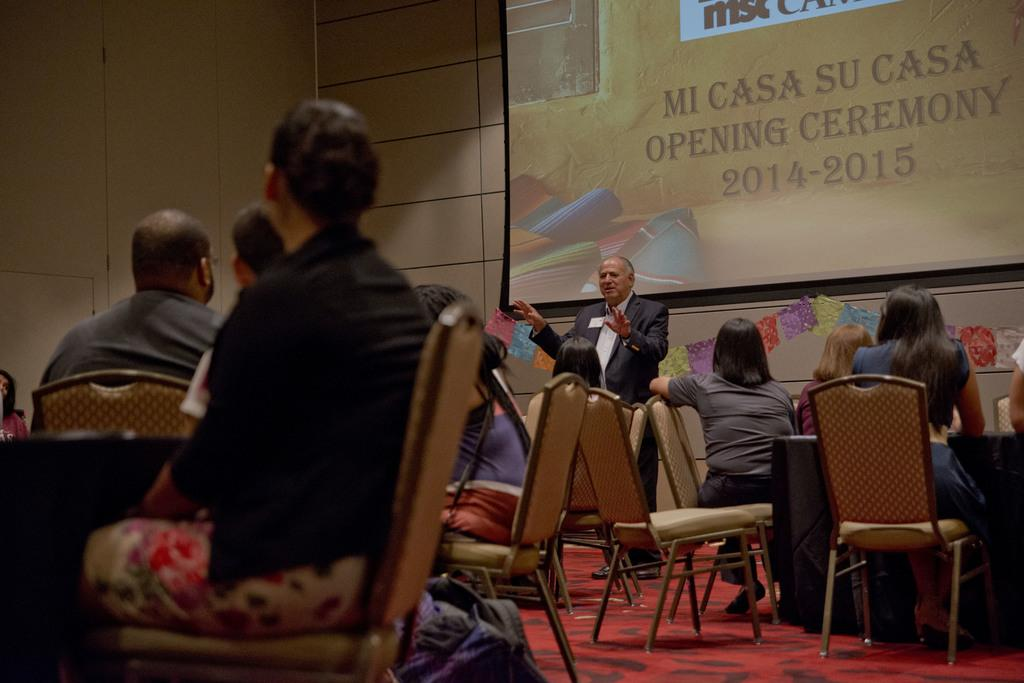What are most of the persons in the image doing? Most persons are sitting on chairs. What can be seen in front of one person? There is a table in front of one person. What is on the wall in the image? There is a banner on the wall. What is located beside one chair? There is a bag beside one chair. What is the standing person wearing? The standing person is wearing a suit. What type of oatmeal is being served at the church in the image? There is no oatmeal or church present in the image. How many people are attending the church service in the image? There is no church or church service present in the image. 